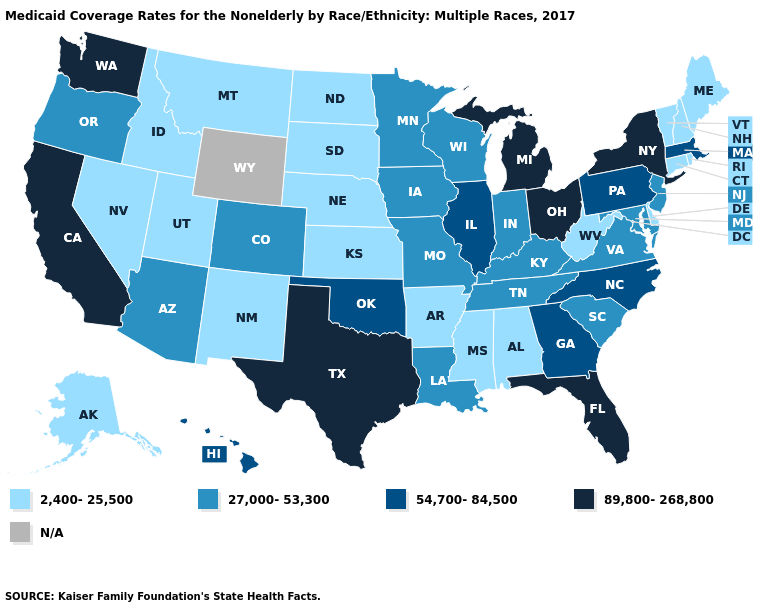What is the lowest value in the USA?
Give a very brief answer. 2,400-25,500. Name the states that have a value in the range 2,400-25,500?
Concise answer only. Alabama, Alaska, Arkansas, Connecticut, Delaware, Idaho, Kansas, Maine, Mississippi, Montana, Nebraska, Nevada, New Hampshire, New Mexico, North Dakota, Rhode Island, South Dakota, Utah, Vermont, West Virginia. Name the states that have a value in the range N/A?
Write a very short answer. Wyoming. Name the states that have a value in the range 89,800-268,800?
Answer briefly. California, Florida, Michigan, New York, Ohio, Texas, Washington. Name the states that have a value in the range 2,400-25,500?
Quick response, please. Alabama, Alaska, Arkansas, Connecticut, Delaware, Idaho, Kansas, Maine, Mississippi, Montana, Nebraska, Nevada, New Hampshire, New Mexico, North Dakota, Rhode Island, South Dakota, Utah, Vermont, West Virginia. What is the highest value in the USA?
Short answer required. 89,800-268,800. Does the map have missing data?
Give a very brief answer. Yes. Name the states that have a value in the range 2,400-25,500?
Concise answer only. Alabama, Alaska, Arkansas, Connecticut, Delaware, Idaho, Kansas, Maine, Mississippi, Montana, Nebraska, Nevada, New Hampshire, New Mexico, North Dakota, Rhode Island, South Dakota, Utah, Vermont, West Virginia. Name the states that have a value in the range 27,000-53,300?
Quick response, please. Arizona, Colorado, Indiana, Iowa, Kentucky, Louisiana, Maryland, Minnesota, Missouri, New Jersey, Oregon, South Carolina, Tennessee, Virginia, Wisconsin. Name the states that have a value in the range 27,000-53,300?
Short answer required. Arizona, Colorado, Indiana, Iowa, Kentucky, Louisiana, Maryland, Minnesota, Missouri, New Jersey, Oregon, South Carolina, Tennessee, Virginia, Wisconsin. What is the value of Iowa?
Answer briefly. 27,000-53,300. What is the value of Connecticut?
Answer briefly. 2,400-25,500. 